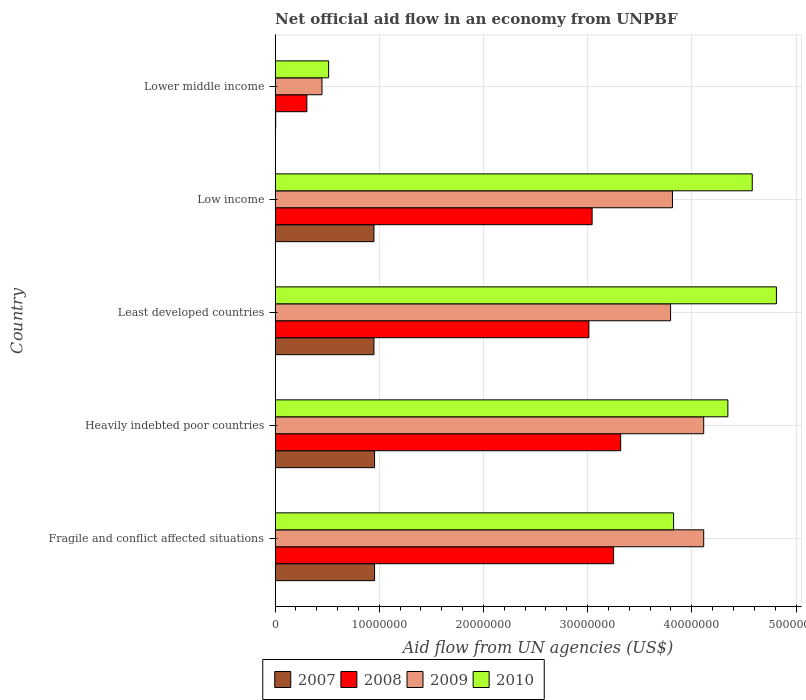How many groups of bars are there?
Provide a succinct answer. 5. Are the number of bars per tick equal to the number of legend labels?
Give a very brief answer. Yes. Are the number of bars on each tick of the Y-axis equal?
Your answer should be very brief. Yes. How many bars are there on the 5th tick from the top?
Give a very brief answer. 4. What is the label of the 1st group of bars from the top?
Your answer should be compact. Lower middle income. What is the net official aid flow in 2007 in Least developed countries?
Offer a very short reply. 9.49e+06. Across all countries, what is the maximum net official aid flow in 2009?
Give a very brief answer. 4.11e+07. Across all countries, what is the minimum net official aid flow in 2009?
Provide a short and direct response. 4.50e+06. In which country was the net official aid flow in 2007 maximum?
Provide a short and direct response. Fragile and conflict affected situations. In which country was the net official aid flow in 2009 minimum?
Keep it short and to the point. Lower middle income. What is the total net official aid flow in 2010 in the graph?
Ensure brevity in your answer.  1.81e+08. What is the difference between the net official aid flow in 2009 in Heavily indebted poor countries and that in Lower middle income?
Your answer should be compact. 3.66e+07. What is the difference between the net official aid flow in 2010 in Heavily indebted poor countries and the net official aid flow in 2007 in Least developed countries?
Provide a succinct answer. 3.40e+07. What is the average net official aid flow in 2007 per country?
Your answer should be very brief. 7.63e+06. What is the difference between the net official aid flow in 2010 and net official aid flow in 2007 in Fragile and conflict affected situations?
Provide a succinct answer. 2.87e+07. What is the ratio of the net official aid flow in 2010 in Least developed countries to that in Low income?
Offer a very short reply. 1.05. What is the difference between the highest and the lowest net official aid flow in 2010?
Your response must be concise. 4.30e+07. In how many countries, is the net official aid flow in 2007 greater than the average net official aid flow in 2007 taken over all countries?
Your answer should be very brief. 4. Is the sum of the net official aid flow in 2009 in Heavily indebted poor countries and Low income greater than the maximum net official aid flow in 2008 across all countries?
Offer a very short reply. Yes. How many countries are there in the graph?
Your response must be concise. 5. Does the graph contain grids?
Make the answer very short. Yes. What is the title of the graph?
Make the answer very short. Net official aid flow in an economy from UNPBF. What is the label or title of the X-axis?
Give a very brief answer. Aid flow from UN agencies (US$). What is the Aid flow from UN agencies (US$) of 2007 in Fragile and conflict affected situations?
Offer a terse response. 9.55e+06. What is the Aid flow from UN agencies (US$) of 2008 in Fragile and conflict affected situations?
Provide a short and direct response. 3.25e+07. What is the Aid flow from UN agencies (US$) in 2009 in Fragile and conflict affected situations?
Make the answer very short. 4.11e+07. What is the Aid flow from UN agencies (US$) in 2010 in Fragile and conflict affected situations?
Ensure brevity in your answer.  3.82e+07. What is the Aid flow from UN agencies (US$) of 2007 in Heavily indebted poor countries?
Your answer should be very brief. 9.55e+06. What is the Aid flow from UN agencies (US$) in 2008 in Heavily indebted poor countries?
Your answer should be very brief. 3.32e+07. What is the Aid flow from UN agencies (US$) of 2009 in Heavily indebted poor countries?
Give a very brief answer. 4.11e+07. What is the Aid flow from UN agencies (US$) of 2010 in Heavily indebted poor countries?
Give a very brief answer. 4.35e+07. What is the Aid flow from UN agencies (US$) of 2007 in Least developed countries?
Offer a terse response. 9.49e+06. What is the Aid flow from UN agencies (US$) in 2008 in Least developed countries?
Provide a succinct answer. 3.01e+07. What is the Aid flow from UN agencies (US$) in 2009 in Least developed countries?
Your answer should be very brief. 3.80e+07. What is the Aid flow from UN agencies (US$) of 2010 in Least developed countries?
Ensure brevity in your answer.  4.81e+07. What is the Aid flow from UN agencies (US$) in 2007 in Low income?
Your response must be concise. 9.49e+06. What is the Aid flow from UN agencies (US$) of 2008 in Low income?
Provide a succinct answer. 3.04e+07. What is the Aid flow from UN agencies (US$) in 2009 in Low income?
Ensure brevity in your answer.  3.81e+07. What is the Aid flow from UN agencies (US$) in 2010 in Low income?
Your answer should be very brief. 4.58e+07. What is the Aid flow from UN agencies (US$) in 2007 in Lower middle income?
Provide a short and direct response. 6.00e+04. What is the Aid flow from UN agencies (US$) in 2008 in Lower middle income?
Your answer should be very brief. 3.05e+06. What is the Aid flow from UN agencies (US$) of 2009 in Lower middle income?
Your response must be concise. 4.50e+06. What is the Aid flow from UN agencies (US$) in 2010 in Lower middle income?
Offer a very short reply. 5.14e+06. Across all countries, what is the maximum Aid flow from UN agencies (US$) of 2007?
Provide a succinct answer. 9.55e+06. Across all countries, what is the maximum Aid flow from UN agencies (US$) of 2008?
Keep it short and to the point. 3.32e+07. Across all countries, what is the maximum Aid flow from UN agencies (US$) of 2009?
Keep it short and to the point. 4.11e+07. Across all countries, what is the maximum Aid flow from UN agencies (US$) in 2010?
Offer a terse response. 4.81e+07. Across all countries, what is the minimum Aid flow from UN agencies (US$) of 2007?
Offer a very short reply. 6.00e+04. Across all countries, what is the minimum Aid flow from UN agencies (US$) of 2008?
Provide a succinct answer. 3.05e+06. Across all countries, what is the minimum Aid flow from UN agencies (US$) in 2009?
Keep it short and to the point. 4.50e+06. Across all countries, what is the minimum Aid flow from UN agencies (US$) in 2010?
Ensure brevity in your answer.  5.14e+06. What is the total Aid flow from UN agencies (US$) of 2007 in the graph?
Keep it short and to the point. 3.81e+07. What is the total Aid flow from UN agencies (US$) in 2008 in the graph?
Your response must be concise. 1.29e+08. What is the total Aid flow from UN agencies (US$) in 2009 in the graph?
Your response must be concise. 1.63e+08. What is the total Aid flow from UN agencies (US$) in 2010 in the graph?
Give a very brief answer. 1.81e+08. What is the difference between the Aid flow from UN agencies (US$) of 2007 in Fragile and conflict affected situations and that in Heavily indebted poor countries?
Provide a short and direct response. 0. What is the difference between the Aid flow from UN agencies (US$) of 2008 in Fragile and conflict affected situations and that in Heavily indebted poor countries?
Keep it short and to the point. -6.80e+05. What is the difference between the Aid flow from UN agencies (US$) in 2010 in Fragile and conflict affected situations and that in Heavily indebted poor countries?
Offer a terse response. -5.21e+06. What is the difference between the Aid flow from UN agencies (US$) of 2008 in Fragile and conflict affected situations and that in Least developed countries?
Your answer should be compact. 2.37e+06. What is the difference between the Aid flow from UN agencies (US$) of 2009 in Fragile and conflict affected situations and that in Least developed countries?
Ensure brevity in your answer.  3.18e+06. What is the difference between the Aid flow from UN agencies (US$) of 2010 in Fragile and conflict affected situations and that in Least developed countries?
Ensure brevity in your answer.  -9.87e+06. What is the difference between the Aid flow from UN agencies (US$) in 2008 in Fragile and conflict affected situations and that in Low income?
Your answer should be compact. 2.06e+06. What is the difference between the Aid flow from UN agencies (US$) of 2010 in Fragile and conflict affected situations and that in Low income?
Your answer should be compact. -7.55e+06. What is the difference between the Aid flow from UN agencies (US$) of 2007 in Fragile and conflict affected situations and that in Lower middle income?
Provide a short and direct response. 9.49e+06. What is the difference between the Aid flow from UN agencies (US$) in 2008 in Fragile and conflict affected situations and that in Lower middle income?
Your answer should be compact. 2.94e+07. What is the difference between the Aid flow from UN agencies (US$) in 2009 in Fragile and conflict affected situations and that in Lower middle income?
Your response must be concise. 3.66e+07. What is the difference between the Aid flow from UN agencies (US$) of 2010 in Fragile and conflict affected situations and that in Lower middle income?
Your answer should be compact. 3.31e+07. What is the difference between the Aid flow from UN agencies (US$) of 2007 in Heavily indebted poor countries and that in Least developed countries?
Your answer should be compact. 6.00e+04. What is the difference between the Aid flow from UN agencies (US$) in 2008 in Heavily indebted poor countries and that in Least developed countries?
Make the answer very short. 3.05e+06. What is the difference between the Aid flow from UN agencies (US$) of 2009 in Heavily indebted poor countries and that in Least developed countries?
Ensure brevity in your answer.  3.18e+06. What is the difference between the Aid flow from UN agencies (US$) of 2010 in Heavily indebted poor countries and that in Least developed countries?
Ensure brevity in your answer.  -4.66e+06. What is the difference between the Aid flow from UN agencies (US$) of 2008 in Heavily indebted poor countries and that in Low income?
Your response must be concise. 2.74e+06. What is the difference between the Aid flow from UN agencies (US$) in 2009 in Heavily indebted poor countries and that in Low income?
Your response must be concise. 3.00e+06. What is the difference between the Aid flow from UN agencies (US$) of 2010 in Heavily indebted poor countries and that in Low income?
Your answer should be very brief. -2.34e+06. What is the difference between the Aid flow from UN agencies (US$) of 2007 in Heavily indebted poor countries and that in Lower middle income?
Give a very brief answer. 9.49e+06. What is the difference between the Aid flow from UN agencies (US$) of 2008 in Heavily indebted poor countries and that in Lower middle income?
Give a very brief answer. 3.01e+07. What is the difference between the Aid flow from UN agencies (US$) of 2009 in Heavily indebted poor countries and that in Lower middle income?
Provide a succinct answer. 3.66e+07. What is the difference between the Aid flow from UN agencies (US$) of 2010 in Heavily indebted poor countries and that in Lower middle income?
Make the answer very short. 3.83e+07. What is the difference between the Aid flow from UN agencies (US$) in 2008 in Least developed countries and that in Low income?
Ensure brevity in your answer.  -3.10e+05. What is the difference between the Aid flow from UN agencies (US$) in 2009 in Least developed countries and that in Low income?
Keep it short and to the point. -1.80e+05. What is the difference between the Aid flow from UN agencies (US$) of 2010 in Least developed countries and that in Low income?
Offer a very short reply. 2.32e+06. What is the difference between the Aid flow from UN agencies (US$) in 2007 in Least developed countries and that in Lower middle income?
Ensure brevity in your answer.  9.43e+06. What is the difference between the Aid flow from UN agencies (US$) in 2008 in Least developed countries and that in Lower middle income?
Your answer should be compact. 2.71e+07. What is the difference between the Aid flow from UN agencies (US$) of 2009 in Least developed countries and that in Lower middle income?
Give a very brief answer. 3.35e+07. What is the difference between the Aid flow from UN agencies (US$) in 2010 in Least developed countries and that in Lower middle income?
Your answer should be very brief. 4.30e+07. What is the difference between the Aid flow from UN agencies (US$) in 2007 in Low income and that in Lower middle income?
Provide a succinct answer. 9.43e+06. What is the difference between the Aid flow from UN agencies (US$) of 2008 in Low income and that in Lower middle income?
Provide a short and direct response. 2.74e+07. What is the difference between the Aid flow from UN agencies (US$) of 2009 in Low income and that in Lower middle income?
Ensure brevity in your answer.  3.36e+07. What is the difference between the Aid flow from UN agencies (US$) of 2010 in Low income and that in Lower middle income?
Ensure brevity in your answer.  4.07e+07. What is the difference between the Aid flow from UN agencies (US$) of 2007 in Fragile and conflict affected situations and the Aid flow from UN agencies (US$) of 2008 in Heavily indebted poor countries?
Provide a short and direct response. -2.36e+07. What is the difference between the Aid flow from UN agencies (US$) of 2007 in Fragile and conflict affected situations and the Aid flow from UN agencies (US$) of 2009 in Heavily indebted poor countries?
Your answer should be very brief. -3.16e+07. What is the difference between the Aid flow from UN agencies (US$) of 2007 in Fragile and conflict affected situations and the Aid flow from UN agencies (US$) of 2010 in Heavily indebted poor countries?
Give a very brief answer. -3.39e+07. What is the difference between the Aid flow from UN agencies (US$) of 2008 in Fragile and conflict affected situations and the Aid flow from UN agencies (US$) of 2009 in Heavily indebted poor countries?
Provide a short and direct response. -8.65e+06. What is the difference between the Aid flow from UN agencies (US$) of 2008 in Fragile and conflict affected situations and the Aid flow from UN agencies (US$) of 2010 in Heavily indebted poor countries?
Keep it short and to the point. -1.10e+07. What is the difference between the Aid flow from UN agencies (US$) in 2009 in Fragile and conflict affected situations and the Aid flow from UN agencies (US$) in 2010 in Heavily indebted poor countries?
Make the answer very short. -2.32e+06. What is the difference between the Aid flow from UN agencies (US$) of 2007 in Fragile and conflict affected situations and the Aid flow from UN agencies (US$) of 2008 in Least developed countries?
Your answer should be very brief. -2.06e+07. What is the difference between the Aid flow from UN agencies (US$) in 2007 in Fragile and conflict affected situations and the Aid flow from UN agencies (US$) in 2009 in Least developed countries?
Offer a very short reply. -2.84e+07. What is the difference between the Aid flow from UN agencies (US$) in 2007 in Fragile and conflict affected situations and the Aid flow from UN agencies (US$) in 2010 in Least developed countries?
Ensure brevity in your answer.  -3.86e+07. What is the difference between the Aid flow from UN agencies (US$) in 2008 in Fragile and conflict affected situations and the Aid flow from UN agencies (US$) in 2009 in Least developed countries?
Your answer should be compact. -5.47e+06. What is the difference between the Aid flow from UN agencies (US$) of 2008 in Fragile and conflict affected situations and the Aid flow from UN agencies (US$) of 2010 in Least developed countries?
Make the answer very short. -1.56e+07. What is the difference between the Aid flow from UN agencies (US$) of 2009 in Fragile and conflict affected situations and the Aid flow from UN agencies (US$) of 2010 in Least developed countries?
Your answer should be very brief. -6.98e+06. What is the difference between the Aid flow from UN agencies (US$) of 2007 in Fragile and conflict affected situations and the Aid flow from UN agencies (US$) of 2008 in Low income?
Keep it short and to the point. -2.09e+07. What is the difference between the Aid flow from UN agencies (US$) in 2007 in Fragile and conflict affected situations and the Aid flow from UN agencies (US$) in 2009 in Low income?
Make the answer very short. -2.86e+07. What is the difference between the Aid flow from UN agencies (US$) in 2007 in Fragile and conflict affected situations and the Aid flow from UN agencies (US$) in 2010 in Low income?
Provide a succinct answer. -3.62e+07. What is the difference between the Aid flow from UN agencies (US$) in 2008 in Fragile and conflict affected situations and the Aid flow from UN agencies (US$) in 2009 in Low income?
Keep it short and to the point. -5.65e+06. What is the difference between the Aid flow from UN agencies (US$) in 2008 in Fragile and conflict affected situations and the Aid flow from UN agencies (US$) in 2010 in Low income?
Keep it short and to the point. -1.33e+07. What is the difference between the Aid flow from UN agencies (US$) in 2009 in Fragile and conflict affected situations and the Aid flow from UN agencies (US$) in 2010 in Low income?
Offer a terse response. -4.66e+06. What is the difference between the Aid flow from UN agencies (US$) of 2007 in Fragile and conflict affected situations and the Aid flow from UN agencies (US$) of 2008 in Lower middle income?
Keep it short and to the point. 6.50e+06. What is the difference between the Aid flow from UN agencies (US$) of 2007 in Fragile and conflict affected situations and the Aid flow from UN agencies (US$) of 2009 in Lower middle income?
Offer a very short reply. 5.05e+06. What is the difference between the Aid flow from UN agencies (US$) of 2007 in Fragile and conflict affected situations and the Aid flow from UN agencies (US$) of 2010 in Lower middle income?
Make the answer very short. 4.41e+06. What is the difference between the Aid flow from UN agencies (US$) of 2008 in Fragile and conflict affected situations and the Aid flow from UN agencies (US$) of 2009 in Lower middle income?
Keep it short and to the point. 2.80e+07. What is the difference between the Aid flow from UN agencies (US$) in 2008 in Fragile and conflict affected situations and the Aid flow from UN agencies (US$) in 2010 in Lower middle income?
Your response must be concise. 2.74e+07. What is the difference between the Aid flow from UN agencies (US$) of 2009 in Fragile and conflict affected situations and the Aid flow from UN agencies (US$) of 2010 in Lower middle income?
Ensure brevity in your answer.  3.60e+07. What is the difference between the Aid flow from UN agencies (US$) of 2007 in Heavily indebted poor countries and the Aid flow from UN agencies (US$) of 2008 in Least developed countries?
Provide a succinct answer. -2.06e+07. What is the difference between the Aid flow from UN agencies (US$) in 2007 in Heavily indebted poor countries and the Aid flow from UN agencies (US$) in 2009 in Least developed countries?
Ensure brevity in your answer.  -2.84e+07. What is the difference between the Aid flow from UN agencies (US$) in 2007 in Heavily indebted poor countries and the Aid flow from UN agencies (US$) in 2010 in Least developed countries?
Your answer should be compact. -3.86e+07. What is the difference between the Aid flow from UN agencies (US$) in 2008 in Heavily indebted poor countries and the Aid flow from UN agencies (US$) in 2009 in Least developed countries?
Provide a short and direct response. -4.79e+06. What is the difference between the Aid flow from UN agencies (US$) in 2008 in Heavily indebted poor countries and the Aid flow from UN agencies (US$) in 2010 in Least developed countries?
Provide a short and direct response. -1.50e+07. What is the difference between the Aid flow from UN agencies (US$) in 2009 in Heavily indebted poor countries and the Aid flow from UN agencies (US$) in 2010 in Least developed countries?
Give a very brief answer. -6.98e+06. What is the difference between the Aid flow from UN agencies (US$) of 2007 in Heavily indebted poor countries and the Aid flow from UN agencies (US$) of 2008 in Low income?
Keep it short and to the point. -2.09e+07. What is the difference between the Aid flow from UN agencies (US$) in 2007 in Heavily indebted poor countries and the Aid flow from UN agencies (US$) in 2009 in Low income?
Your response must be concise. -2.86e+07. What is the difference between the Aid flow from UN agencies (US$) of 2007 in Heavily indebted poor countries and the Aid flow from UN agencies (US$) of 2010 in Low income?
Give a very brief answer. -3.62e+07. What is the difference between the Aid flow from UN agencies (US$) of 2008 in Heavily indebted poor countries and the Aid flow from UN agencies (US$) of 2009 in Low income?
Give a very brief answer. -4.97e+06. What is the difference between the Aid flow from UN agencies (US$) of 2008 in Heavily indebted poor countries and the Aid flow from UN agencies (US$) of 2010 in Low income?
Your answer should be compact. -1.26e+07. What is the difference between the Aid flow from UN agencies (US$) in 2009 in Heavily indebted poor countries and the Aid flow from UN agencies (US$) in 2010 in Low income?
Make the answer very short. -4.66e+06. What is the difference between the Aid flow from UN agencies (US$) of 2007 in Heavily indebted poor countries and the Aid flow from UN agencies (US$) of 2008 in Lower middle income?
Your answer should be very brief. 6.50e+06. What is the difference between the Aid flow from UN agencies (US$) in 2007 in Heavily indebted poor countries and the Aid flow from UN agencies (US$) in 2009 in Lower middle income?
Your answer should be very brief. 5.05e+06. What is the difference between the Aid flow from UN agencies (US$) in 2007 in Heavily indebted poor countries and the Aid flow from UN agencies (US$) in 2010 in Lower middle income?
Provide a short and direct response. 4.41e+06. What is the difference between the Aid flow from UN agencies (US$) of 2008 in Heavily indebted poor countries and the Aid flow from UN agencies (US$) of 2009 in Lower middle income?
Your response must be concise. 2.87e+07. What is the difference between the Aid flow from UN agencies (US$) of 2008 in Heavily indebted poor countries and the Aid flow from UN agencies (US$) of 2010 in Lower middle income?
Your response must be concise. 2.80e+07. What is the difference between the Aid flow from UN agencies (US$) of 2009 in Heavily indebted poor countries and the Aid flow from UN agencies (US$) of 2010 in Lower middle income?
Provide a succinct answer. 3.60e+07. What is the difference between the Aid flow from UN agencies (US$) in 2007 in Least developed countries and the Aid flow from UN agencies (US$) in 2008 in Low income?
Provide a succinct answer. -2.09e+07. What is the difference between the Aid flow from UN agencies (US$) in 2007 in Least developed countries and the Aid flow from UN agencies (US$) in 2009 in Low income?
Offer a terse response. -2.86e+07. What is the difference between the Aid flow from UN agencies (US$) of 2007 in Least developed countries and the Aid flow from UN agencies (US$) of 2010 in Low income?
Your answer should be very brief. -3.63e+07. What is the difference between the Aid flow from UN agencies (US$) of 2008 in Least developed countries and the Aid flow from UN agencies (US$) of 2009 in Low income?
Your answer should be compact. -8.02e+06. What is the difference between the Aid flow from UN agencies (US$) of 2008 in Least developed countries and the Aid flow from UN agencies (US$) of 2010 in Low income?
Provide a succinct answer. -1.57e+07. What is the difference between the Aid flow from UN agencies (US$) of 2009 in Least developed countries and the Aid flow from UN agencies (US$) of 2010 in Low income?
Your response must be concise. -7.84e+06. What is the difference between the Aid flow from UN agencies (US$) of 2007 in Least developed countries and the Aid flow from UN agencies (US$) of 2008 in Lower middle income?
Your response must be concise. 6.44e+06. What is the difference between the Aid flow from UN agencies (US$) of 2007 in Least developed countries and the Aid flow from UN agencies (US$) of 2009 in Lower middle income?
Keep it short and to the point. 4.99e+06. What is the difference between the Aid flow from UN agencies (US$) of 2007 in Least developed countries and the Aid flow from UN agencies (US$) of 2010 in Lower middle income?
Keep it short and to the point. 4.35e+06. What is the difference between the Aid flow from UN agencies (US$) in 2008 in Least developed countries and the Aid flow from UN agencies (US$) in 2009 in Lower middle income?
Offer a terse response. 2.56e+07. What is the difference between the Aid flow from UN agencies (US$) in 2008 in Least developed countries and the Aid flow from UN agencies (US$) in 2010 in Lower middle income?
Make the answer very short. 2.50e+07. What is the difference between the Aid flow from UN agencies (US$) of 2009 in Least developed countries and the Aid flow from UN agencies (US$) of 2010 in Lower middle income?
Provide a short and direct response. 3.28e+07. What is the difference between the Aid flow from UN agencies (US$) of 2007 in Low income and the Aid flow from UN agencies (US$) of 2008 in Lower middle income?
Offer a terse response. 6.44e+06. What is the difference between the Aid flow from UN agencies (US$) in 2007 in Low income and the Aid flow from UN agencies (US$) in 2009 in Lower middle income?
Offer a very short reply. 4.99e+06. What is the difference between the Aid flow from UN agencies (US$) in 2007 in Low income and the Aid flow from UN agencies (US$) in 2010 in Lower middle income?
Ensure brevity in your answer.  4.35e+06. What is the difference between the Aid flow from UN agencies (US$) of 2008 in Low income and the Aid flow from UN agencies (US$) of 2009 in Lower middle income?
Keep it short and to the point. 2.59e+07. What is the difference between the Aid flow from UN agencies (US$) in 2008 in Low income and the Aid flow from UN agencies (US$) in 2010 in Lower middle income?
Make the answer very short. 2.53e+07. What is the difference between the Aid flow from UN agencies (US$) in 2009 in Low income and the Aid flow from UN agencies (US$) in 2010 in Lower middle income?
Your response must be concise. 3.30e+07. What is the average Aid flow from UN agencies (US$) in 2007 per country?
Your answer should be compact. 7.63e+06. What is the average Aid flow from UN agencies (US$) of 2008 per country?
Keep it short and to the point. 2.59e+07. What is the average Aid flow from UN agencies (US$) in 2009 per country?
Make the answer very short. 3.26e+07. What is the average Aid flow from UN agencies (US$) of 2010 per country?
Ensure brevity in your answer.  3.62e+07. What is the difference between the Aid flow from UN agencies (US$) in 2007 and Aid flow from UN agencies (US$) in 2008 in Fragile and conflict affected situations?
Your response must be concise. -2.29e+07. What is the difference between the Aid flow from UN agencies (US$) of 2007 and Aid flow from UN agencies (US$) of 2009 in Fragile and conflict affected situations?
Provide a succinct answer. -3.16e+07. What is the difference between the Aid flow from UN agencies (US$) of 2007 and Aid flow from UN agencies (US$) of 2010 in Fragile and conflict affected situations?
Give a very brief answer. -2.87e+07. What is the difference between the Aid flow from UN agencies (US$) in 2008 and Aid flow from UN agencies (US$) in 2009 in Fragile and conflict affected situations?
Provide a succinct answer. -8.65e+06. What is the difference between the Aid flow from UN agencies (US$) of 2008 and Aid flow from UN agencies (US$) of 2010 in Fragile and conflict affected situations?
Give a very brief answer. -5.76e+06. What is the difference between the Aid flow from UN agencies (US$) of 2009 and Aid flow from UN agencies (US$) of 2010 in Fragile and conflict affected situations?
Your answer should be compact. 2.89e+06. What is the difference between the Aid flow from UN agencies (US$) of 2007 and Aid flow from UN agencies (US$) of 2008 in Heavily indebted poor countries?
Provide a succinct answer. -2.36e+07. What is the difference between the Aid flow from UN agencies (US$) in 2007 and Aid flow from UN agencies (US$) in 2009 in Heavily indebted poor countries?
Your response must be concise. -3.16e+07. What is the difference between the Aid flow from UN agencies (US$) in 2007 and Aid flow from UN agencies (US$) in 2010 in Heavily indebted poor countries?
Offer a terse response. -3.39e+07. What is the difference between the Aid flow from UN agencies (US$) of 2008 and Aid flow from UN agencies (US$) of 2009 in Heavily indebted poor countries?
Provide a short and direct response. -7.97e+06. What is the difference between the Aid flow from UN agencies (US$) of 2008 and Aid flow from UN agencies (US$) of 2010 in Heavily indebted poor countries?
Keep it short and to the point. -1.03e+07. What is the difference between the Aid flow from UN agencies (US$) of 2009 and Aid flow from UN agencies (US$) of 2010 in Heavily indebted poor countries?
Your answer should be compact. -2.32e+06. What is the difference between the Aid flow from UN agencies (US$) in 2007 and Aid flow from UN agencies (US$) in 2008 in Least developed countries?
Your answer should be compact. -2.06e+07. What is the difference between the Aid flow from UN agencies (US$) of 2007 and Aid flow from UN agencies (US$) of 2009 in Least developed countries?
Make the answer very short. -2.85e+07. What is the difference between the Aid flow from UN agencies (US$) in 2007 and Aid flow from UN agencies (US$) in 2010 in Least developed countries?
Provide a succinct answer. -3.86e+07. What is the difference between the Aid flow from UN agencies (US$) in 2008 and Aid flow from UN agencies (US$) in 2009 in Least developed countries?
Provide a short and direct response. -7.84e+06. What is the difference between the Aid flow from UN agencies (US$) in 2008 and Aid flow from UN agencies (US$) in 2010 in Least developed countries?
Your answer should be very brief. -1.80e+07. What is the difference between the Aid flow from UN agencies (US$) of 2009 and Aid flow from UN agencies (US$) of 2010 in Least developed countries?
Provide a short and direct response. -1.02e+07. What is the difference between the Aid flow from UN agencies (US$) of 2007 and Aid flow from UN agencies (US$) of 2008 in Low income?
Your answer should be very brief. -2.09e+07. What is the difference between the Aid flow from UN agencies (US$) in 2007 and Aid flow from UN agencies (US$) in 2009 in Low income?
Keep it short and to the point. -2.86e+07. What is the difference between the Aid flow from UN agencies (US$) in 2007 and Aid flow from UN agencies (US$) in 2010 in Low income?
Offer a terse response. -3.63e+07. What is the difference between the Aid flow from UN agencies (US$) of 2008 and Aid flow from UN agencies (US$) of 2009 in Low income?
Keep it short and to the point. -7.71e+06. What is the difference between the Aid flow from UN agencies (US$) in 2008 and Aid flow from UN agencies (US$) in 2010 in Low income?
Provide a succinct answer. -1.54e+07. What is the difference between the Aid flow from UN agencies (US$) of 2009 and Aid flow from UN agencies (US$) of 2010 in Low income?
Provide a succinct answer. -7.66e+06. What is the difference between the Aid flow from UN agencies (US$) in 2007 and Aid flow from UN agencies (US$) in 2008 in Lower middle income?
Keep it short and to the point. -2.99e+06. What is the difference between the Aid flow from UN agencies (US$) of 2007 and Aid flow from UN agencies (US$) of 2009 in Lower middle income?
Offer a very short reply. -4.44e+06. What is the difference between the Aid flow from UN agencies (US$) in 2007 and Aid flow from UN agencies (US$) in 2010 in Lower middle income?
Your response must be concise. -5.08e+06. What is the difference between the Aid flow from UN agencies (US$) of 2008 and Aid flow from UN agencies (US$) of 2009 in Lower middle income?
Keep it short and to the point. -1.45e+06. What is the difference between the Aid flow from UN agencies (US$) in 2008 and Aid flow from UN agencies (US$) in 2010 in Lower middle income?
Keep it short and to the point. -2.09e+06. What is the difference between the Aid flow from UN agencies (US$) in 2009 and Aid flow from UN agencies (US$) in 2010 in Lower middle income?
Provide a short and direct response. -6.40e+05. What is the ratio of the Aid flow from UN agencies (US$) of 2008 in Fragile and conflict affected situations to that in Heavily indebted poor countries?
Make the answer very short. 0.98. What is the ratio of the Aid flow from UN agencies (US$) of 2010 in Fragile and conflict affected situations to that in Heavily indebted poor countries?
Your response must be concise. 0.88. What is the ratio of the Aid flow from UN agencies (US$) of 2007 in Fragile and conflict affected situations to that in Least developed countries?
Your response must be concise. 1.01. What is the ratio of the Aid flow from UN agencies (US$) of 2008 in Fragile and conflict affected situations to that in Least developed countries?
Offer a terse response. 1.08. What is the ratio of the Aid flow from UN agencies (US$) of 2009 in Fragile and conflict affected situations to that in Least developed countries?
Provide a succinct answer. 1.08. What is the ratio of the Aid flow from UN agencies (US$) of 2010 in Fragile and conflict affected situations to that in Least developed countries?
Provide a short and direct response. 0.79. What is the ratio of the Aid flow from UN agencies (US$) of 2007 in Fragile and conflict affected situations to that in Low income?
Give a very brief answer. 1.01. What is the ratio of the Aid flow from UN agencies (US$) in 2008 in Fragile and conflict affected situations to that in Low income?
Provide a succinct answer. 1.07. What is the ratio of the Aid flow from UN agencies (US$) of 2009 in Fragile and conflict affected situations to that in Low income?
Provide a short and direct response. 1.08. What is the ratio of the Aid flow from UN agencies (US$) of 2010 in Fragile and conflict affected situations to that in Low income?
Provide a short and direct response. 0.84. What is the ratio of the Aid flow from UN agencies (US$) in 2007 in Fragile and conflict affected situations to that in Lower middle income?
Offer a terse response. 159.17. What is the ratio of the Aid flow from UN agencies (US$) of 2008 in Fragile and conflict affected situations to that in Lower middle income?
Your response must be concise. 10.65. What is the ratio of the Aid flow from UN agencies (US$) in 2009 in Fragile and conflict affected situations to that in Lower middle income?
Make the answer very short. 9.14. What is the ratio of the Aid flow from UN agencies (US$) in 2010 in Fragile and conflict affected situations to that in Lower middle income?
Make the answer very short. 7.44. What is the ratio of the Aid flow from UN agencies (US$) in 2007 in Heavily indebted poor countries to that in Least developed countries?
Your response must be concise. 1.01. What is the ratio of the Aid flow from UN agencies (US$) of 2008 in Heavily indebted poor countries to that in Least developed countries?
Make the answer very short. 1.1. What is the ratio of the Aid flow from UN agencies (US$) in 2009 in Heavily indebted poor countries to that in Least developed countries?
Keep it short and to the point. 1.08. What is the ratio of the Aid flow from UN agencies (US$) of 2010 in Heavily indebted poor countries to that in Least developed countries?
Make the answer very short. 0.9. What is the ratio of the Aid flow from UN agencies (US$) in 2007 in Heavily indebted poor countries to that in Low income?
Offer a terse response. 1.01. What is the ratio of the Aid flow from UN agencies (US$) of 2008 in Heavily indebted poor countries to that in Low income?
Provide a short and direct response. 1.09. What is the ratio of the Aid flow from UN agencies (US$) in 2009 in Heavily indebted poor countries to that in Low income?
Your response must be concise. 1.08. What is the ratio of the Aid flow from UN agencies (US$) of 2010 in Heavily indebted poor countries to that in Low income?
Your response must be concise. 0.95. What is the ratio of the Aid flow from UN agencies (US$) in 2007 in Heavily indebted poor countries to that in Lower middle income?
Offer a very short reply. 159.17. What is the ratio of the Aid flow from UN agencies (US$) of 2008 in Heavily indebted poor countries to that in Lower middle income?
Offer a very short reply. 10.88. What is the ratio of the Aid flow from UN agencies (US$) of 2009 in Heavily indebted poor countries to that in Lower middle income?
Your answer should be compact. 9.14. What is the ratio of the Aid flow from UN agencies (US$) in 2010 in Heavily indebted poor countries to that in Lower middle income?
Make the answer very short. 8.46. What is the ratio of the Aid flow from UN agencies (US$) of 2007 in Least developed countries to that in Low income?
Ensure brevity in your answer.  1. What is the ratio of the Aid flow from UN agencies (US$) in 2010 in Least developed countries to that in Low income?
Your answer should be very brief. 1.05. What is the ratio of the Aid flow from UN agencies (US$) in 2007 in Least developed countries to that in Lower middle income?
Keep it short and to the point. 158.17. What is the ratio of the Aid flow from UN agencies (US$) of 2008 in Least developed countries to that in Lower middle income?
Ensure brevity in your answer.  9.88. What is the ratio of the Aid flow from UN agencies (US$) in 2009 in Least developed countries to that in Lower middle income?
Make the answer very short. 8.44. What is the ratio of the Aid flow from UN agencies (US$) of 2010 in Least developed countries to that in Lower middle income?
Keep it short and to the point. 9.36. What is the ratio of the Aid flow from UN agencies (US$) in 2007 in Low income to that in Lower middle income?
Provide a short and direct response. 158.17. What is the ratio of the Aid flow from UN agencies (US$) in 2008 in Low income to that in Lower middle income?
Provide a short and direct response. 9.98. What is the ratio of the Aid flow from UN agencies (US$) of 2009 in Low income to that in Lower middle income?
Make the answer very short. 8.48. What is the ratio of the Aid flow from UN agencies (US$) in 2010 in Low income to that in Lower middle income?
Your response must be concise. 8.91. What is the difference between the highest and the second highest Aid flow from UN agencies (US$) in 2007?
Your answer should be compact. 0. What is the difference between the highest and the second highest Aid flow from UN agencies (US$) of 2008?
Provide a succinct answer. 6.80e+05. What is the difference between the highest and the second highest Aid flow from UN agencies (US$) of 2009?
Offer a terse response. 0. What is the difference between the highest and the second highest Aid flow from UN agencies (US$) of 2010?
Your answer should be compact. 2.32e+06. What is the difference between the highest and the lowest Aid flow from UN agencies (US$) in 2007?
Provide a succinct answer. 9.49e+06. What is the difference between the highest and the lowest Aid flow from UN agencies (US$) of 2008?
Ensure brevity in your answer.  3.01e+07. What is the difference between the highest and the lowest Aid flow from UN agencies (US$) of 2009?
Ensure brevity in your answer.  3.66e+07. What is the difference between the highest and the lowest Aid flow from UN agencies (US$) in 2010?
Give a very brief answer. 4.30e+07. 